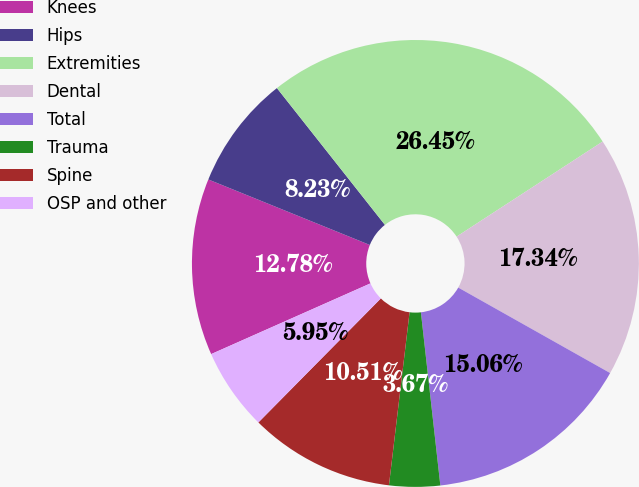<chart> <loc_0><loc_0><loc_500><loc_500><pie_chart><fcel>Knees<fcel>Hips<fcel>Extremities<fcel>Dental<fcel>Total<fcel>Trauma<fcel>Spine<fcel>OSP and other<nl><fcel>12.78%<fcel>8.23%<fcel>26.45%<fcel>17.34%<fcel>15.06%<fcel>3.67%<fcel>10.51%<fcel>5.95%<nl></chart> 